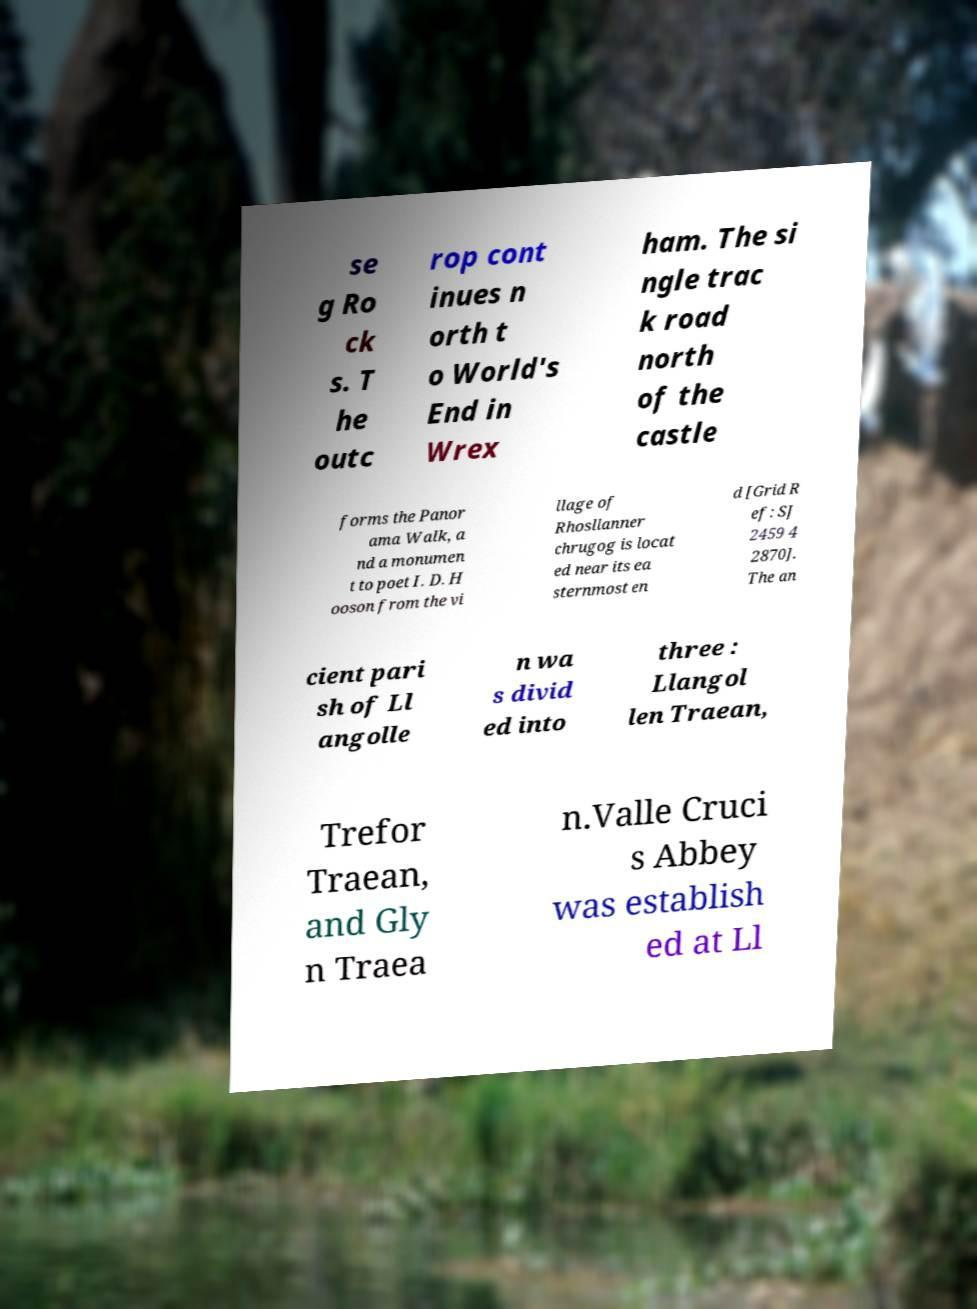Please identify and transcribe the text found in this image. se g Ro ck s. T he outc rop cont inues n orth t o World's End in Wrex ham. The si ngle trac k road north of the castle forms the Panor ama Walk, a nd a monumen t to poet I. D. H ooson from the vi llage of Rhosllanner chrugog is locat ed near its ea sternmost en d [Grid R ef: SJ 2459 4 2870]. The an cient pari sh of Ll angolle n wa s divid ed into three : Llangol len Traean, Trefor Traean, and Gly n Traea n.Valle Cruci s Abbey was establish ed at Ll 